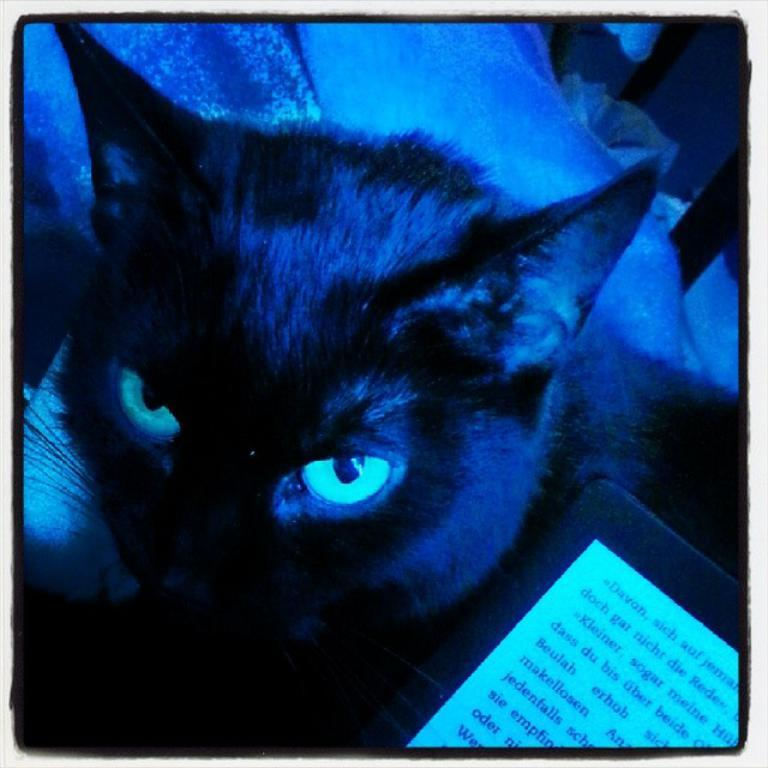What type of animal is present in the image? There is a cat in the image. What other object can be seen in the image? There is a gadget in the image. What is a feature of the gadget? There is a screen in the image. What else is present in the image? There is text in the image. How many fingers can be seen touching the snow in the image? There is no snow or fingers present in the image. 